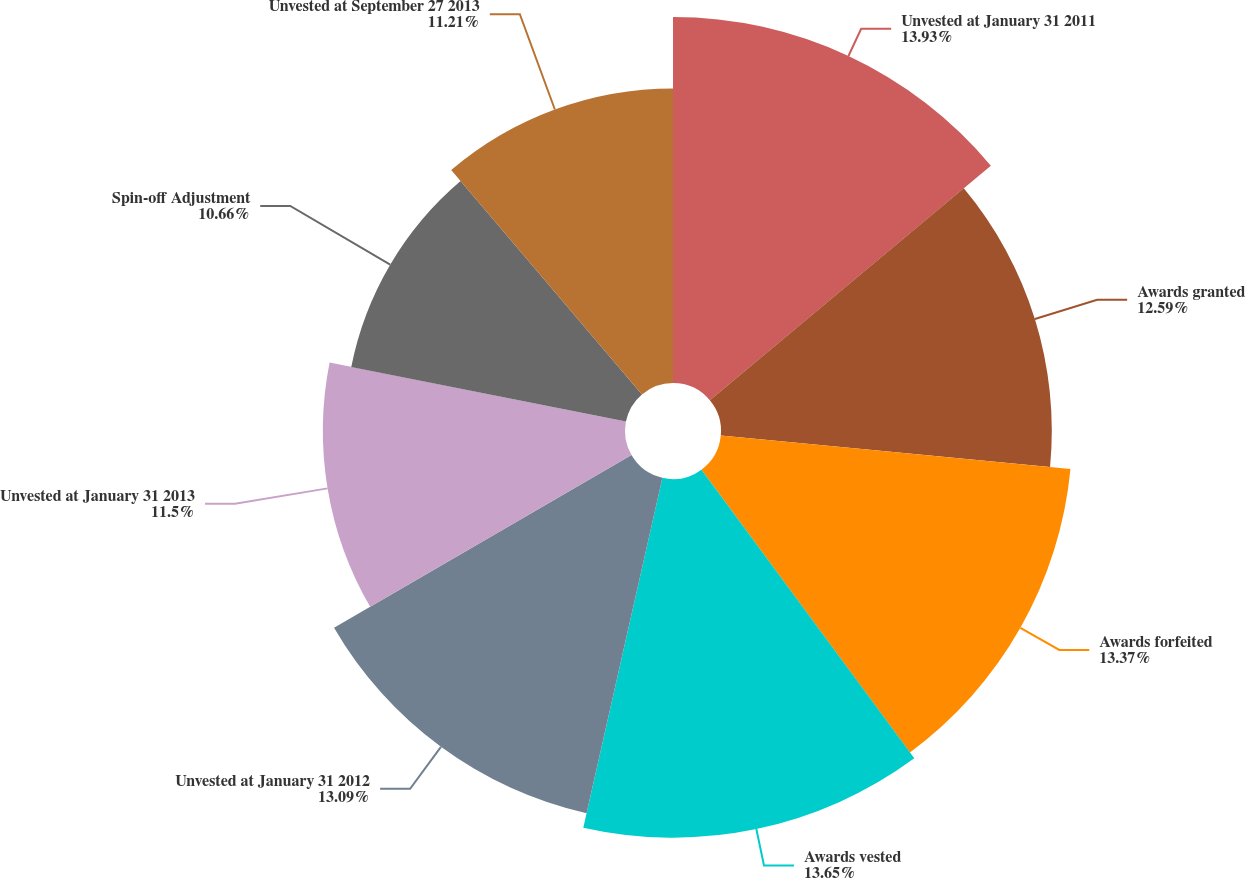Convert chart to OTSL. <chart><loc_0><loc_0><loc_500><loc_500><pie_chart><fcel>Unvested at January 31 2011<fcel>Awards granted<fcel>Awards forfeited<fcel>Awards vested<fcel>Unvested at January 31 2012<fcel>Unvested at January 31 2013<fcel>Spin-off Adjustment<fcel>Unvested at September 27 2013<nl><fcel>13.93%<fcel>12.59%<fcel>13.37%<fcel>13.65%<fcel>13.09%<fcel>11.5%<fcel>10.66%<fcel>11.21%<nl></chart> 